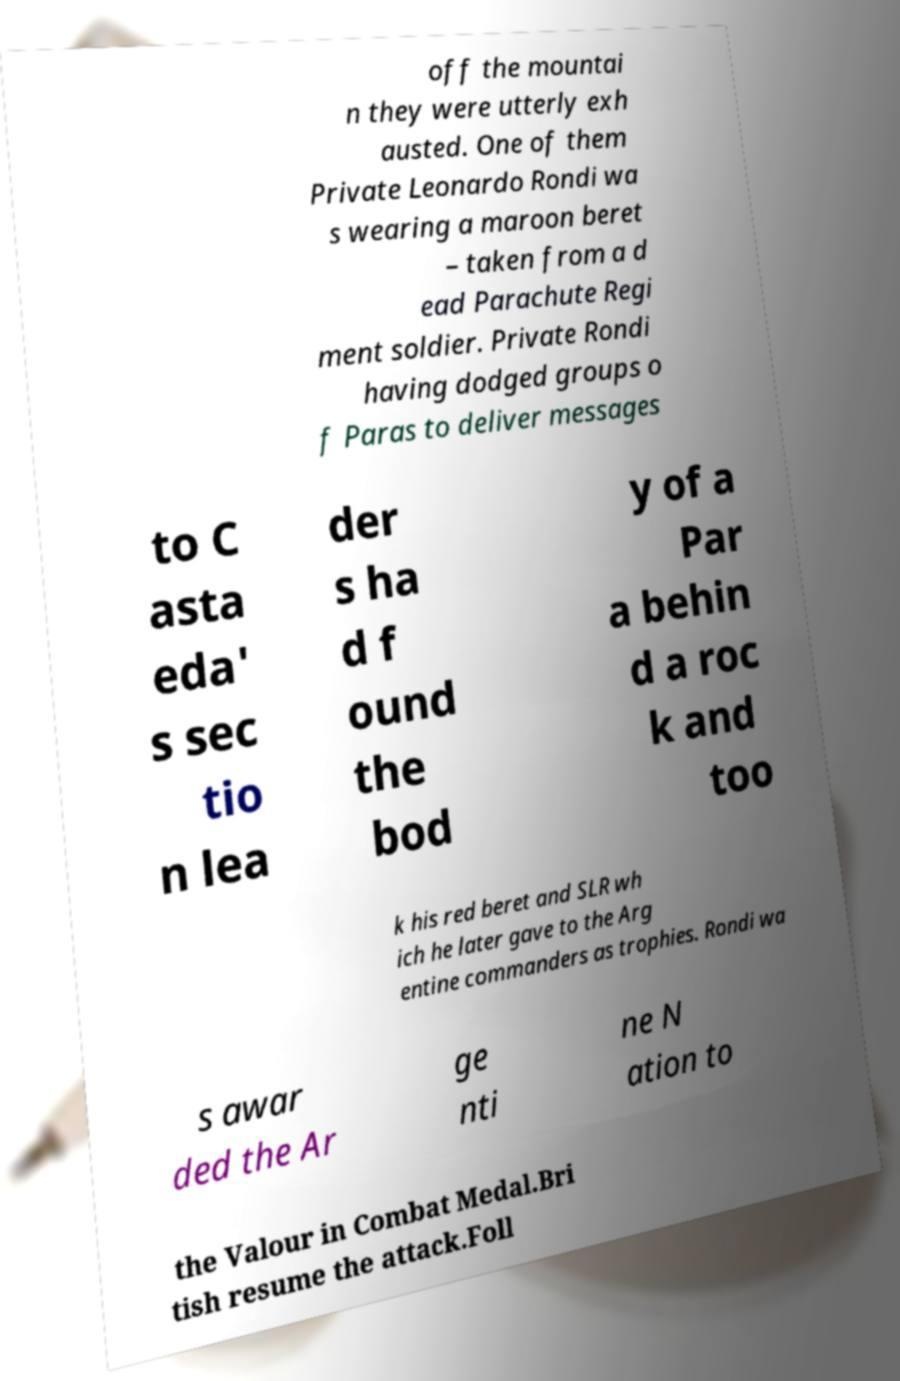I need the written content from this picture converted into text. Can you do that? off the mountai n they were utterly exh austed. One of them Private Leonardo Rondi wa s wearing a maroon beret – taken from a d ead Parachute Regi ment soldier. Private Rondi having dodged groups o f Paras to deliver messages to C asta eda' s sec tio n lea der s ha d f ound the bod y of a Par a behin d a roc k and too k his red beret and SLR wh ich he later gave to the Arg entine commanders as trophies. Rondi wa s awar ded the Ar ge nti ne N ation to the Valour in Combat Medal.Bri tish resume the attack.Foll 